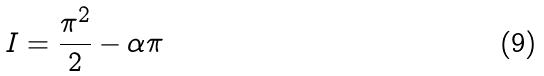<formula> <loc_0><loc_0><loc_500><loc_500>I = \frac { \pi ^ { 2 } } { 2 } - \alpha \pi</formula> 